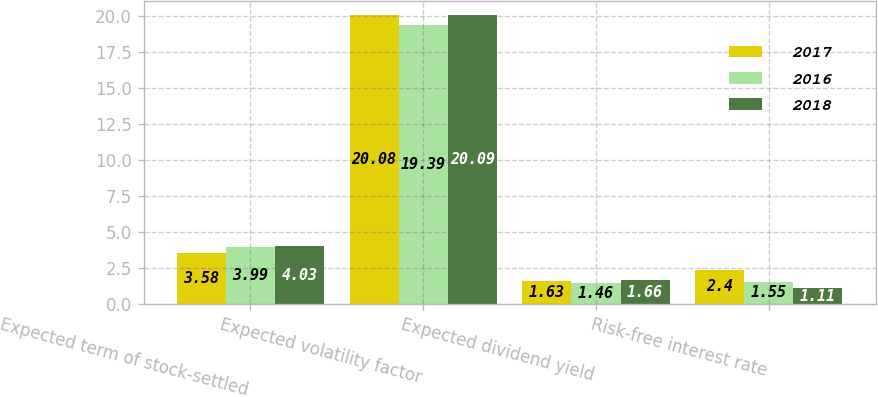Convert chart to OTSL. <chart><loc_0><loc_0><loc_500><loc_500><stacked_bar_chart><ecel><fcel>Expected term of stock-settled<fcel>Expected volatility factor<fcel>Expected dividend yield<fcel>Risk-free interest rate<nl><fcel>2017<fcel>3.58<fcel>20.08<fcel>1.63<fcel>2.4<nl><fcel>2016<fcel>3.99<fcel>19.39<fcel>1.46<fcel>1.55<nl><fcel>2018<fcel>4.03<fcel>20.09<fcel>1.66<fcel>1.11<nl></chart> 